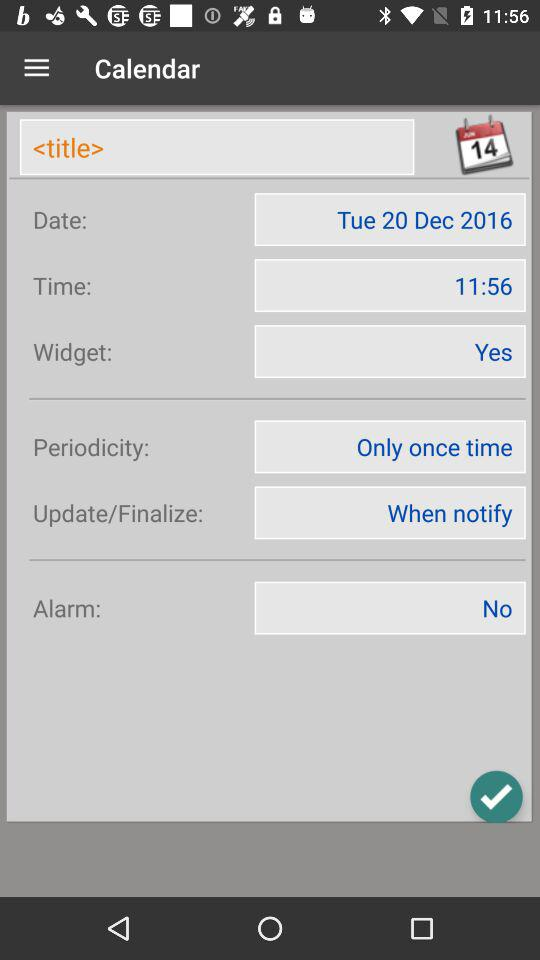What's the time? The time is 11:56. 